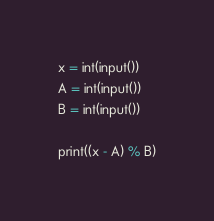Convert code to text. <code><loc_0><loc_0><loc_500><loc_500><_Python_>x = int(input())
A = int(input())
B = int(input())

print((x - A) % B)
</code> 